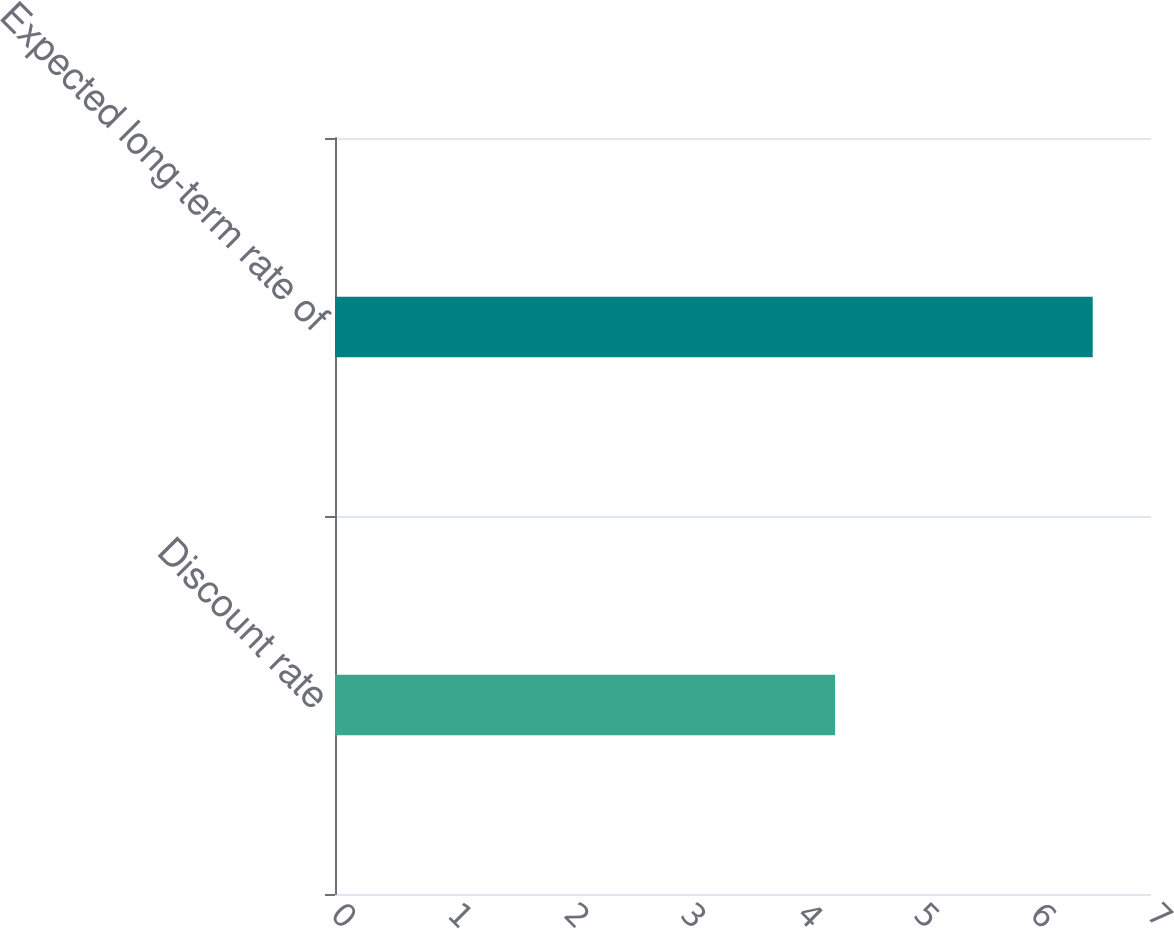Convert chart. <chart><loc_0><loc_0><loc_500><loc_500><bar_chart><fcel>Discount rate<fcel>Expected long-term rate of<nl><fcel>4.29<fcel>6.5<nl></chart> 